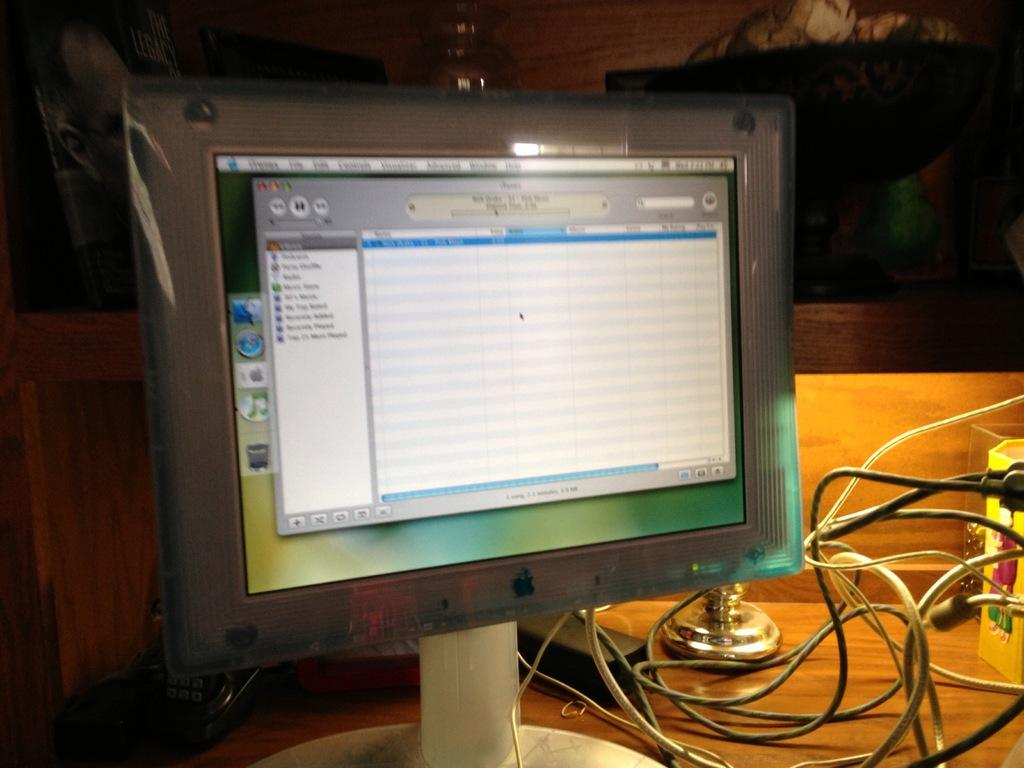What electronic device is on the table in the image? There is a monitor on the table. What else can be seen on the table besides the monitor? There are wires on the table. What type of humor can be seen on the side of the monitor in the image? There is no humor or any text present on the side of the monitor in the image. 